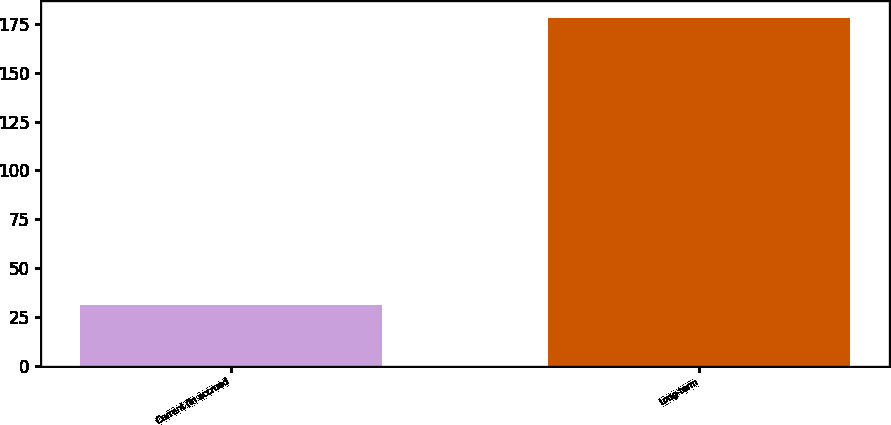Convert chart to OTSL. <chart><loc_0><loc_0><loc_500><loc_500><bar_chart><fcel>Current (in accrued<fcel>Long-term<nl><fcel>31<fcel>178<nl></chart> 